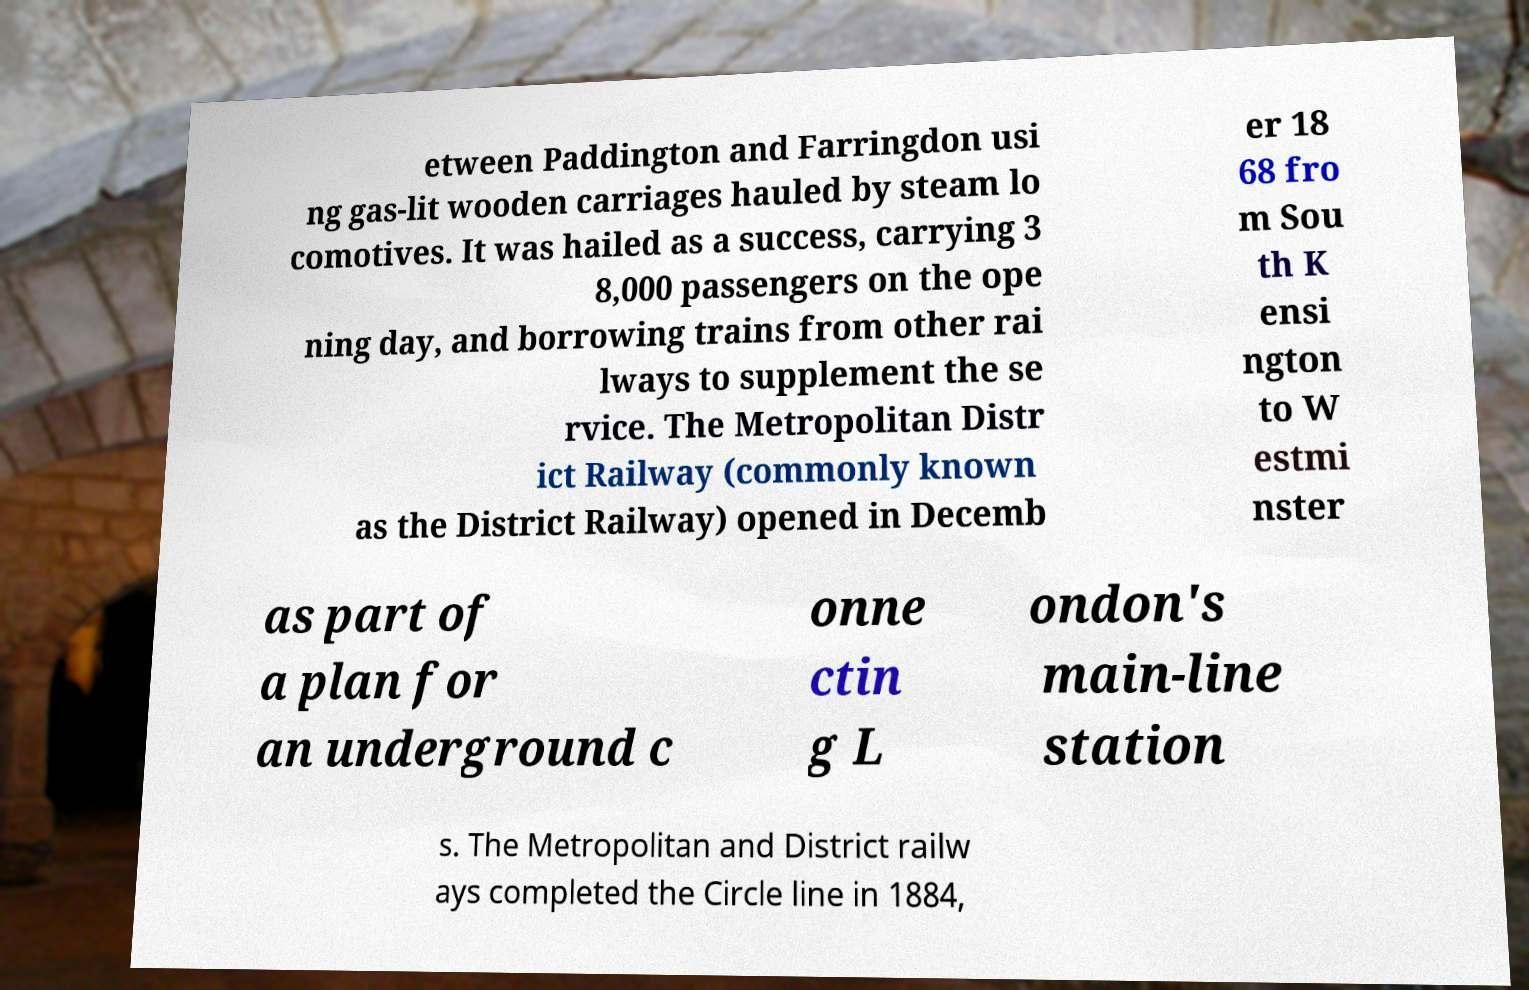For documentation purposes, I need the text within this image transcribed. Could you provide that? etween Paddington and Farringdon usi ng gas-lit wooden carriages hauled by steam lo comotives. It was hailed as a success, carrying 3 8,000 passengers on the ope ning day, and borrowing trains from other rai lways to supplement the se rvice. The Metropolitan Distr ict Railway (commonly known as the District Railway) opened in Decemb er 18 68 fro m Sou th K ensi ngton to W estmi nster as part of a plan for an underground c onne ctin g L ondon's main-line station s. The Metropolitan and District railw ays completed the Circle line in 1884, 